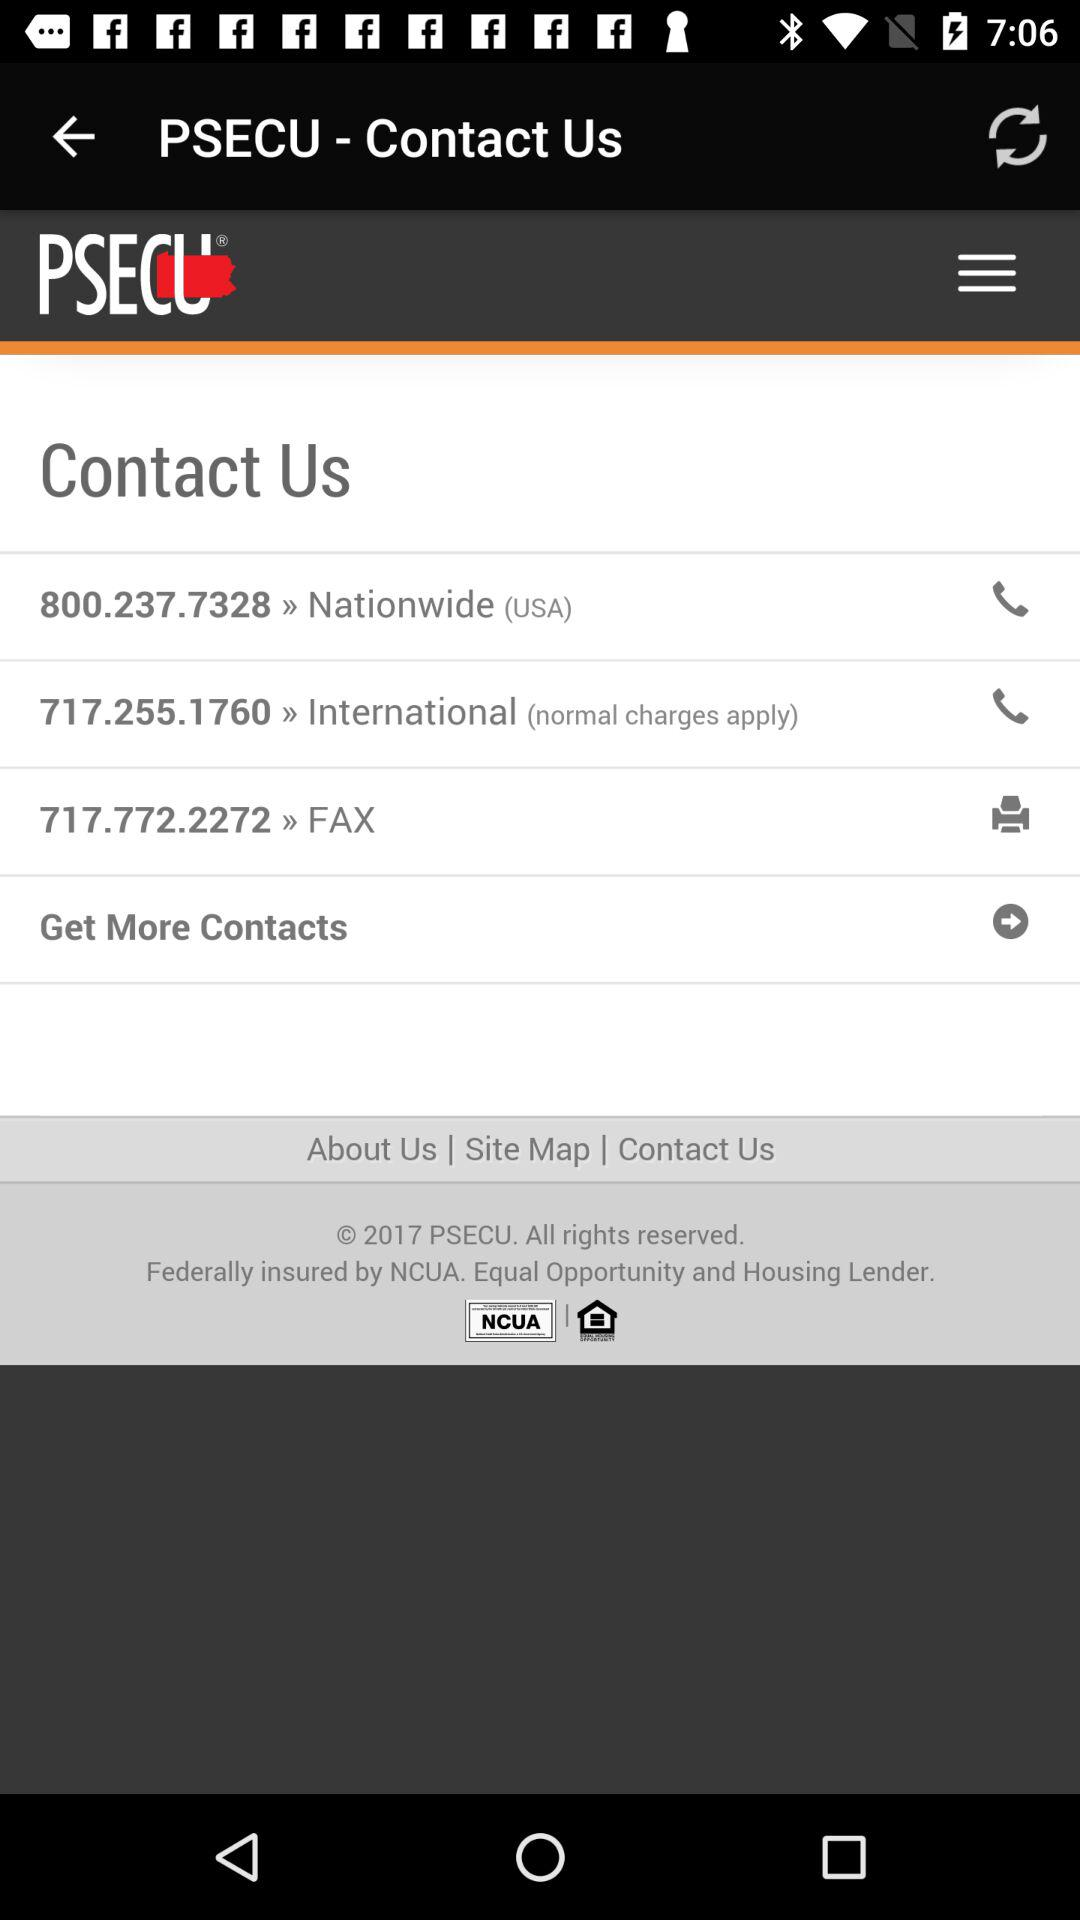How many contact numbers are there for the US?
Answer the question using a single word or phrase. 1 